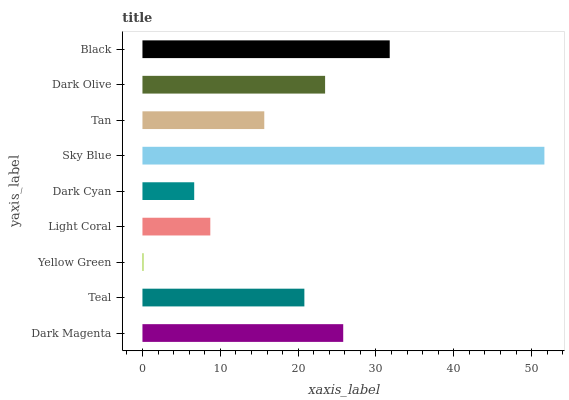Is Yellow Green the minimum?
Answer yes or no. Yes. Is Sky Blue the maximum?
Answer yes or no. Yes. Is Teal the minimum?
Answer yes or no. No. Is Teal the maximum?
Answer yes or no. No. Is Dark Magenta greater than Teal?
Answer yes or no. Yes. Is Teal less than Dark Magenta?
Answer yes or no. Yes. Is Teal greater than Dark Magenta?
Answer yes or no. No. Is Dark Magenta less than Teal?
Answer yes or no. No. Is Teal the high median?
Answer yes or no. Yes. Is Teal the low median?
Answer yes or no. Yes. Is Dark Cyan the high median?
Answer yes or no. No. Is Light Coral the low median?
Answer yes or no. No. 